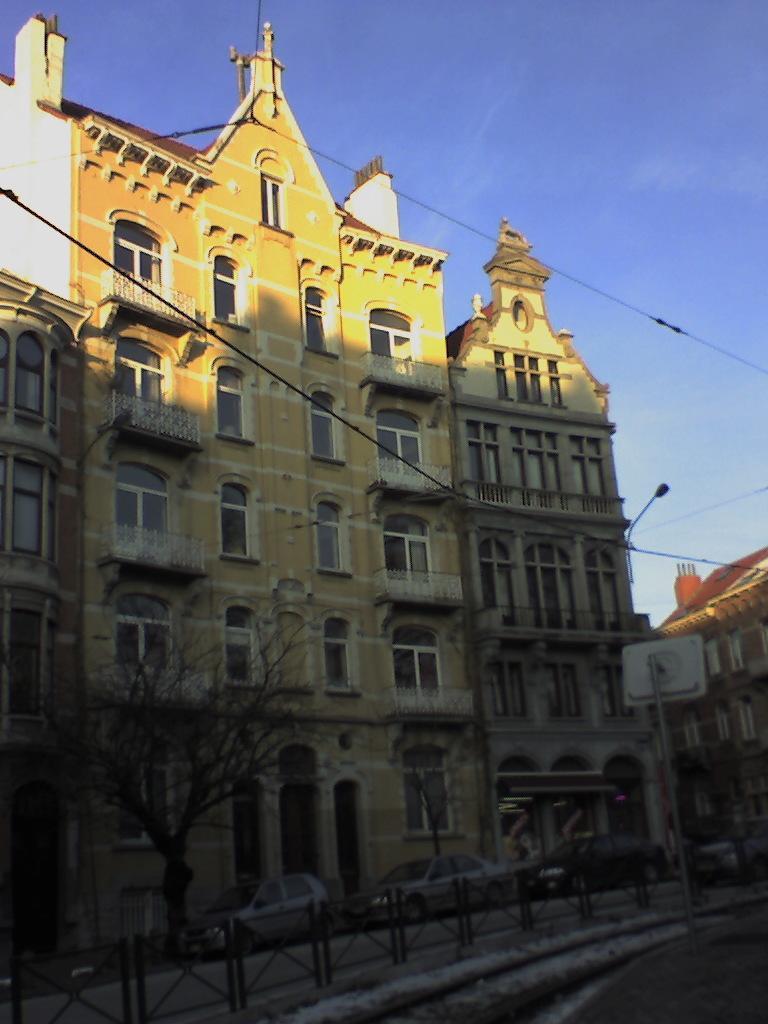How would you summarize this image in a sentence or two? In this image there are some cars on the the bottom of this image and there are some trees on the bottom left side of this image and there is a building in the background. There is a blue sky on the top of this image. 